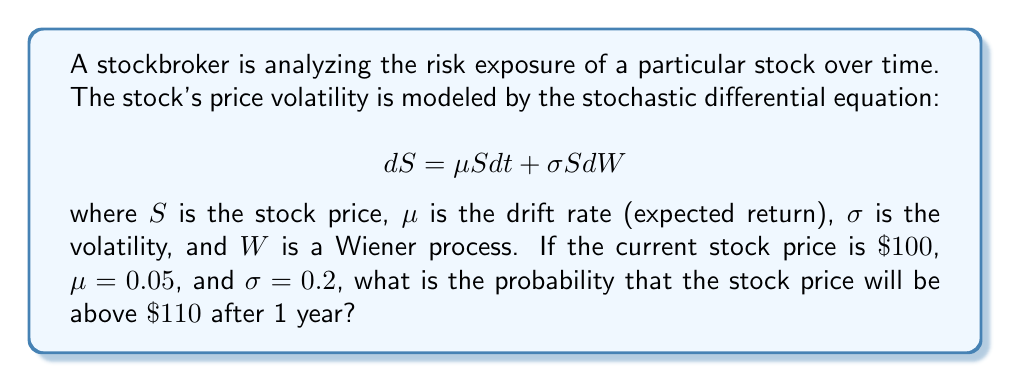Teach me how to tackle this problem. To solve this problem, we need to use the properties of geometric Brownian motion, which is described by the given stochastic differential equation. The solution to this equation follows a lognormal distribution.

1) First, we need to calculate the expected value and variance of the log-return over the 1-year period:

   Expected log-return: $E[\ln(S_T/S_0)] = (\mu - \frac{\sigma^2}{2})T$
   Variance of log-return: $Var[\ln(S_T/S_0)] = \sigma^2 T$

   Where $T = 1$ year, $S_0 = 100$, $\mu = 0.05$, and $\sigma = 0.2$

2) Calculate the expected log-return:
   $E[\ln(S_T/S_0)] = (0.05 - \frac{0.2^2}{2}) \times 1 = 0.03$

3) Calculate the variance of log-return:
   $Var[\ln(S_T/S_0)] = 0.2^2 \times 1 = 0.04$

4) The probability we're looking for is $P(S_T > 110)$, which is equivalent to $P(\ln(S_T/S_0) > \ln(110/100))$

5) We can standardize this to a normal distribution:

   $P(\ln(S_T/S_0) > \ln(1.1)) = P(\frac{\ln(S_T/S_0) - 0.03}{\sqrt{0.04}} > \frac{\ln(1.1) - 0.03}{\sqrt{0.04}})$

6) Calculate the z-score:
   $z = \frac{\ln(1.1) - 0.03}{\sqrt{0.04}} = 0.3162$

7) The probability is then:
   $P(Z > 0.3162) = 1 - \Phi(0.3162)$

   where $\Phi$ is the cumulative distribution function of the standard normal distribution.

8) Using a standard normal table or calculator:
   $1 - \Phi(0.3162) \approx 0.3759$

Therefore, the probability that the stock price will be above $110 after 1 year is approximately 0.3759 or 37.59%.
Answer: The probability that the stock price will be above $110 after 1 year is approximately 0.3759 or 37.59%. 